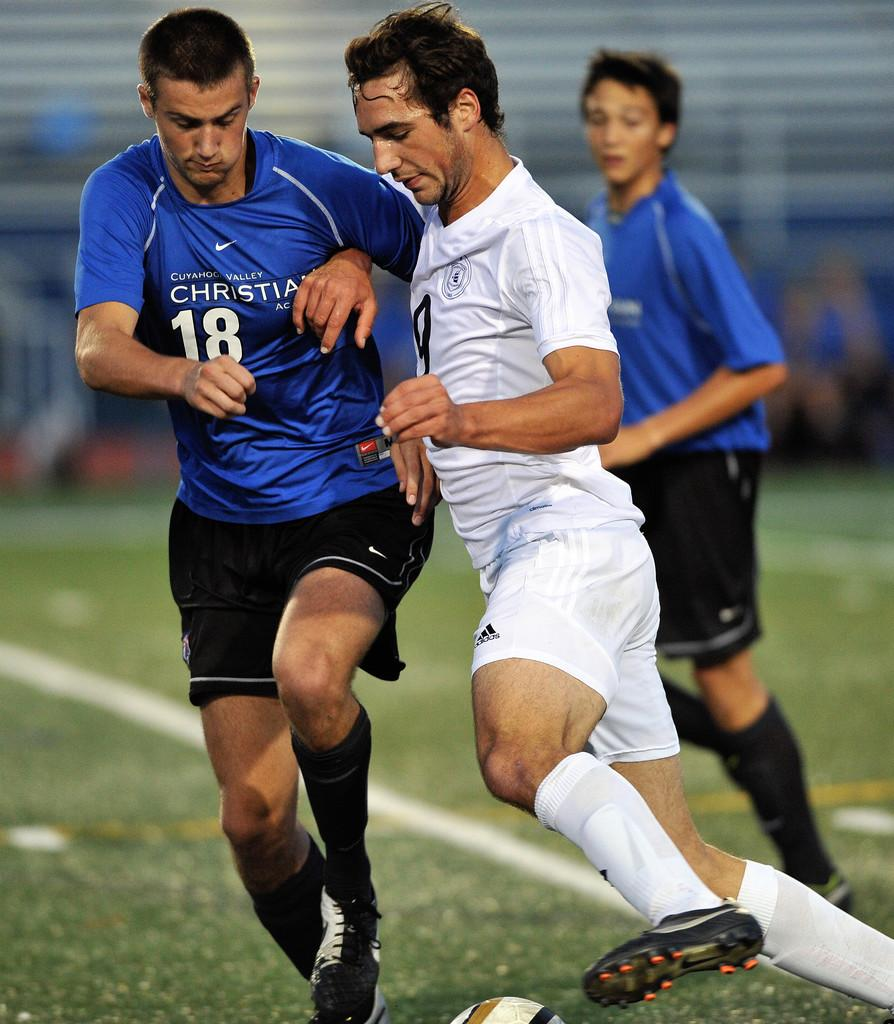<image>
Write a terse but informative summary of the picture. a player that is wearing the number 18 